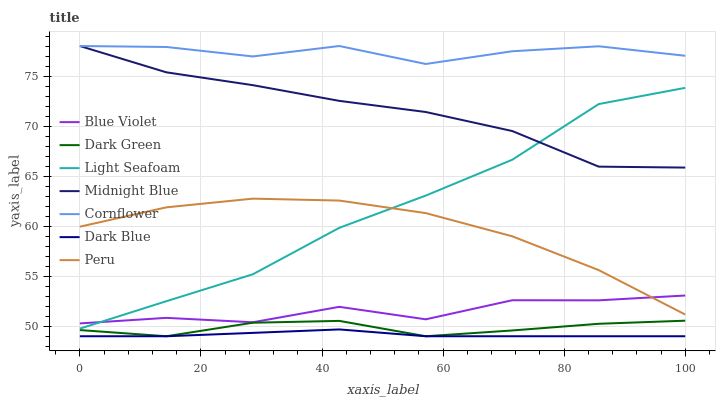Does Dark Blue have the minimum area under the curve?
Answer yes or no. Yes. Does Cornflower have the maximum area under the curve?
Answer yes or no. Yes. Does Midnight Blue have the minimum area under the curve?
Answer yes or no. No. Does Midnight Blue have the maximum area under the curve?
Answer yes or no. No. Is Dark Blue the smoothest?
Answer yes or no. Yes. Is Blue Violet the roughest?
Answer yes or no. Yes. Is Midnight Blue the smoothest?
Answer yes or no. No. Is Midnight Blue the roughest?
Answer yes or no. No. Does Midnight Blue have the lowest value?
Answer yes or no. No. Does Midnight Blue have the highest value?
Answer yes or no. Yes. Does Dark Blue have the highest value?
Answer yes or no. No. Is Peru less than Cornflower?
Answer yes or no. Yes. Is Cornflower greater than Blue Violet?
Answer yes or no. Yes. Does Light Seafoam intersect Blue Violet?
Answer yes or no. Yes. Is Light Seafoam less than Blue Violet?
Answer yes or no. No. Is Light Seafoam greater than Blue Violet?
Answer yes or no. No. Does Peru intersect Cornflower?
Answer yes or no. No. 